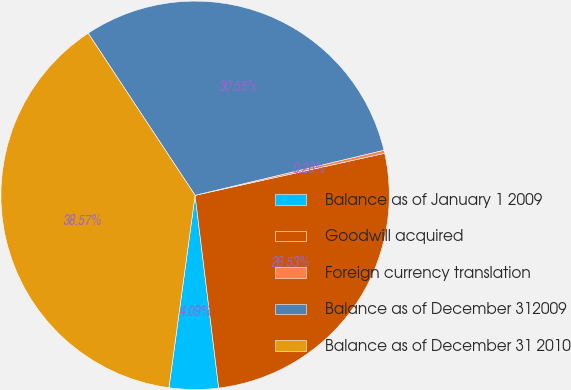Convert chart. <chart><loc_0><loc_0><loc_500><loc_500><pie_chart><fcel>Balance as of January 1 2009<fcel>Goodwill acquired<fcel>Foreign currency translation<fcel>Balance as of December 312009<fcel>Balance as of December 31 2010<nl><fcel>4.09%<fcel>26.53%<fcel>0.26%<fcel>30.55%<fcel>38.57%<nl></chart> 